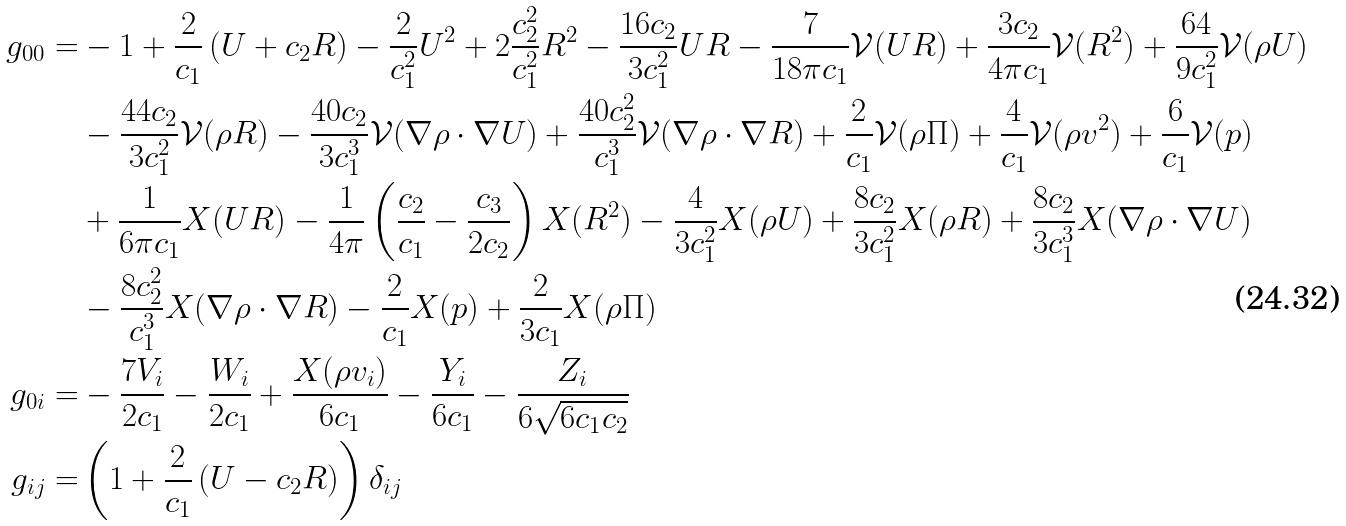Convert formula to latex. <formula><loc_0><loc_0><loc_500><loc_500>g _ { 0 0 } = & - 1 + \frac { 2 } { c _ { 1 } } \left ( U + c _ { 2 } R \right ) - \frac { 2 } { c _ { 1 } ^ { 2 } } U ^ { 2 } + 2 \frac { c _ { 2 } ^ { 2 } } { c _ { 1 } ^ { 2 } } R ^ { 2 } - \frac { 1 6 c _ { 2 } } { 3 c _ { 1 } ^ { 2 } } U R - \frac { 7 } { 1 8 \pi c _ { 1 } } \mathcal { V } ( U R ) + \frac { 3 c _ { 2 } } { 4 \pi c _ { 1 } } \mathcal { V } ( R ^ { 2 } ) + \frac { 6 4 } { 9 c _ { 1 } ^ { 2 } } \mathcal { V } ( \rho U ) \\ & - \frac { 4 4 c _ { 2 } } { 3 c _ { 1 } ^ { 2 } } \mathcal { V } ( \rho R ) - \frac { 4 0 c _ { 2 } } { 3 c _ { 1 } ^ { 3 } } \mathcal { V } ( \nabla \rho \cdot \nabla U ) + \frac { 4 0 c _ { 2 } ^ { 2 } } { c _ { 1 } ^ { 3 } } \mathcal { V } ( \nabla \rho \cdot \nabla R ) + \frac { 2 } { c _ { 1 } } \mathcal { V } ( \rho \Pi ) + \frac { 4 } { c _ { 1 } } \mathcal { V } ( \rho v ^ { 2 } ) + \frac { 6 } { c _ { 1 } } \mathcal { V } ( p ) \\ & + \frac { 1 } { 6 \pi c _ { 1 } } X ( U R ) - \frac { 1 } { 4 \pi } \left ( \frac { c _ { 2 } } { c _ { 1 } } - \frac { c _ { 3 } } { 2 c _ { 2 } } \right ) X ( R ^ { 2 } ) - \frac { 4 } { 3 c _ { 1 } ^ { 2 } } X ( \rho U ) + \frac { 8 c _ { 2 } } { 3 c _ { 1 } ^ { 2 } } X ( \rho R ) + \frac { 8 c _ { 2 } } { 3 c _ { 1 } ^ { 3 } } X ( \nabla \rho \cdot \nabla U ) \\ & - \frac { 8 c _ { 2 } ^ { 2 } } { c _ { 1 } ^ { 3 } } X ( \nabla \rho \cdot \nabla R ) - \frac { 2 } { c _ { 1 } } X ( p ) + \frac { 2 } { 3 c _ { 1 } } X ( \rho \Pi ) \\ g _ { 0 i } = & - \frac { 7 V _ { i } } { 2 c _ { 1 } } - \frac { W _ { i } } { 2 c _ { 1 } } + \frac { X ( \rho v _ { i } ) } { 6 c _ { 1 } } - \frac { Y _ { i } } { 6 c _ { 1 } } - \frac { Z _ { i } } { 6 \sqrt { 6 c _ { 1 } c _ { 2 } } } \\ g _ { i j } = & \left ( 1 + \frac { 2 } { c _ { 1 } } \left ( U - c _ { 2 } R \right ) \right ) \delta _ { i j }</formula> 